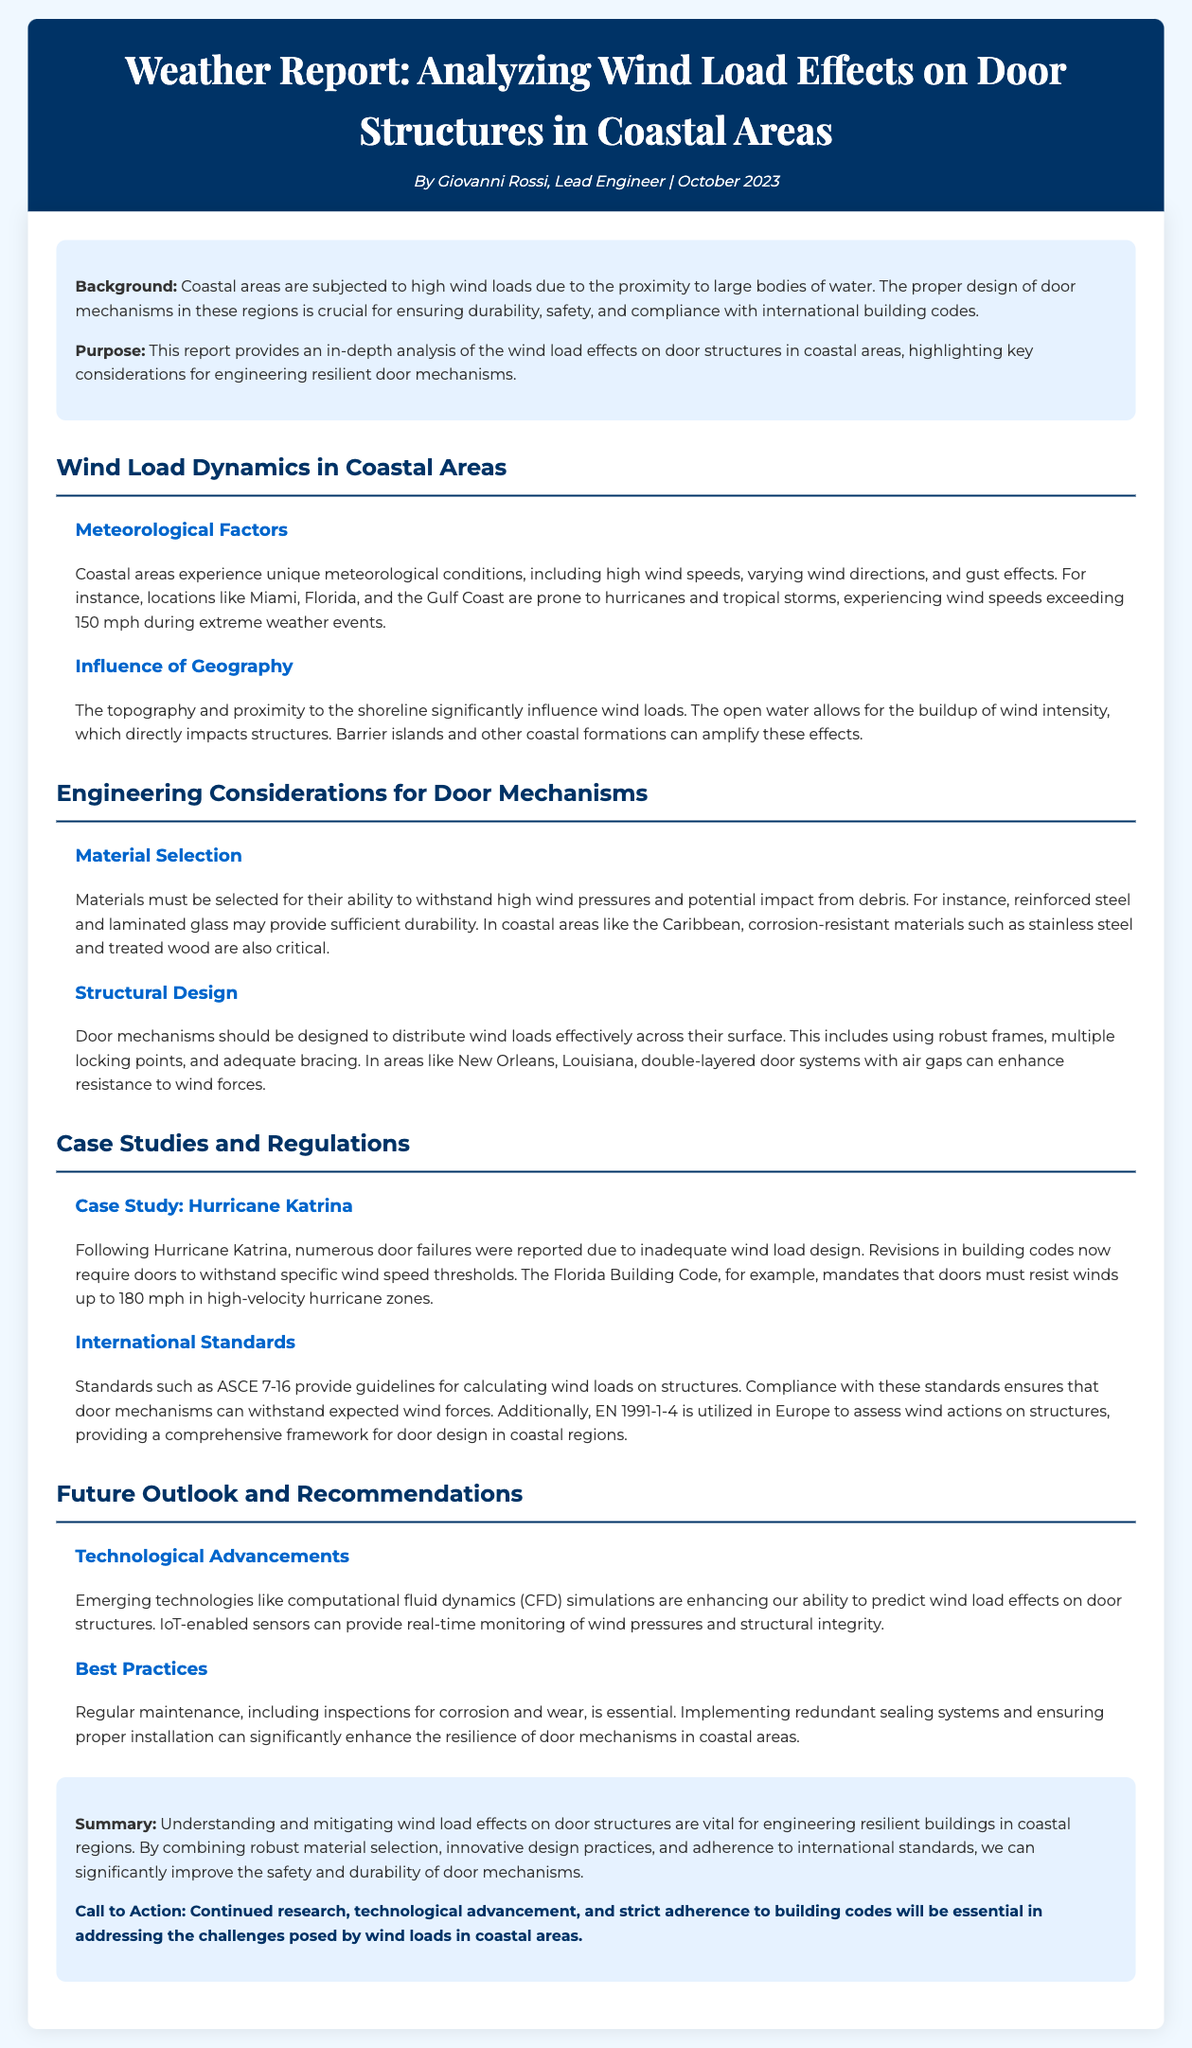What is the title of the report? The title of the report is provided in the header section of the document.
Answer: Weather Report: Analyzing Wind Load Effects on Door Structures in Coastal Areas Who is the author of the report? The author is mentioned in the subheading under the title.
Answer: Giovanni Rossi What is the main purpose of the report? The purpose is outlined in the introduction section.
Answer: To provide an in-depth analysis of the wind load effects on door structures in coastal areas What is the wind speed threshold mandated by the Florida Building Code? This information is found in the "Case Study: Hurricane Katrina" section.
Answer: 180 mph Which technology is mentioned as enhancing the prediction of wind load effects? The specific technology is highlighted in the "Technological Advancements" subsection.
Answer: Computational fluid dynamics (CFD) simulations What material is critical for corrosion resistance in coastal areas? This detail is mentioned under the "Material Selection" subsection.
Answer: Stainless steel What are two best practices for enhancing door mechanism resilience? This summary is provided in the "Best Practices" subsection of the report.
Answer: Regular maintenance and proper installation What do the international standards ASCE 7-16 and EN 1991-1-4 pertain to? The relevance of these standards is discussed in the "International Standards" subsection.
Answer: Wind loads on structures What extreme weather events affect coastal areas mentioned in the report? This is specified in the meteorological factors subsection.
Answer: Hurricanes and tropical storms 